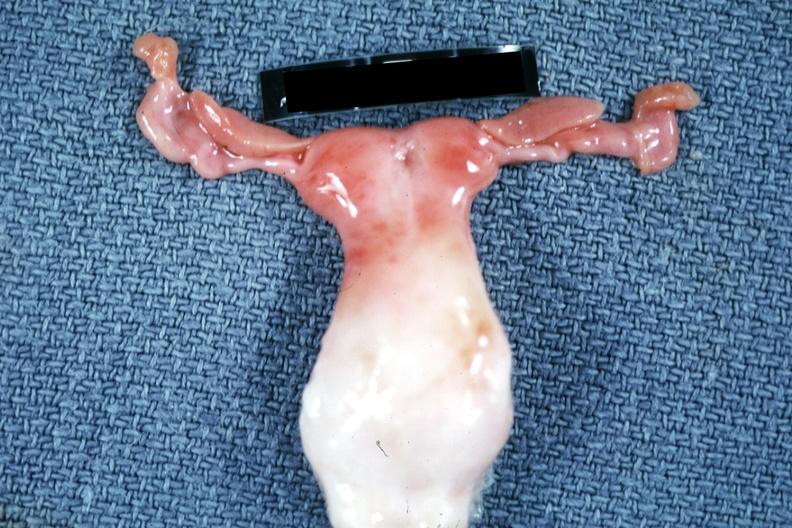what does this image show?
Answer the question using a single word or phrase. Infant bicornate uterus 